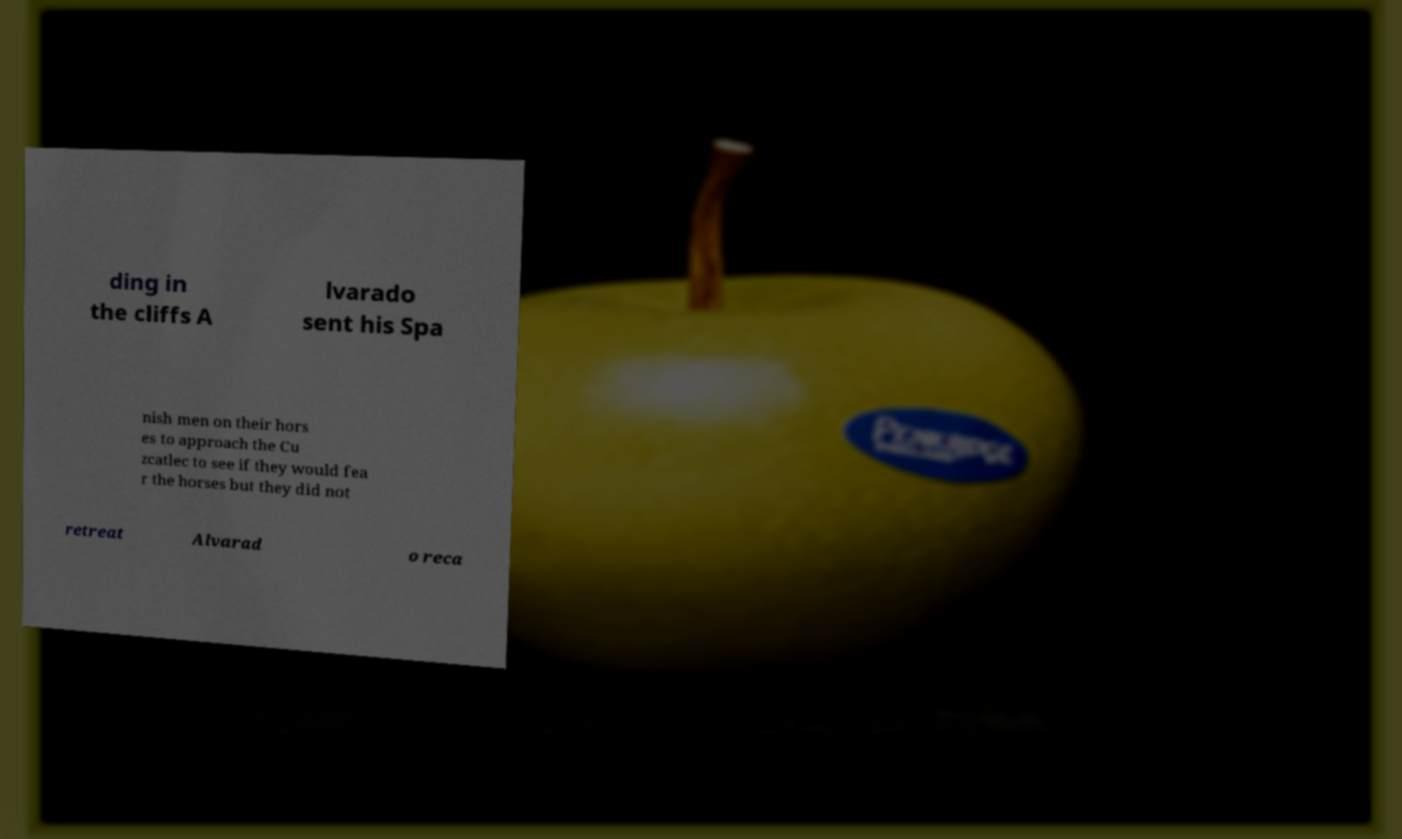Please read and relay the text visible in this image. What does it say? ding in the cliffs A lvarado sent his Spa nish men on their hors es to approach the Cu zcatlec to see if they would fea r the horses but they did not retreat Alvarad o reca 